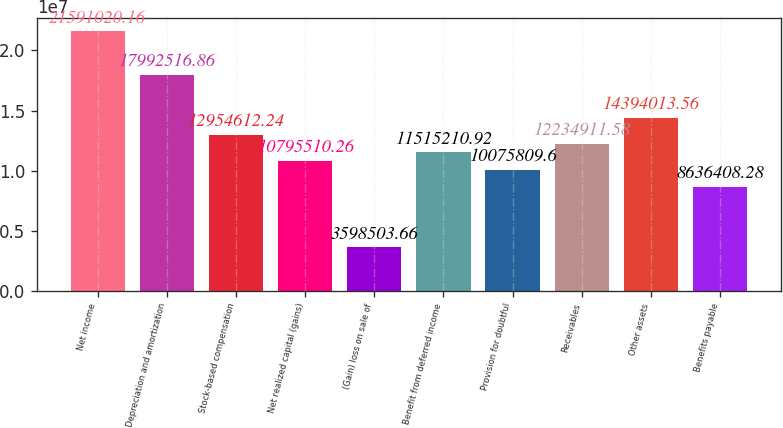Convert chart to OTSL. <chart><loc_0><loc_0><loc_500><loc_500><bar_chart><fcel>Net income<fcel>Depreciation and amortization<fcel>Stock-based compensation<fcel>Net realized capital (gains)<fcel>(Gain) loss on sale of<fcel>Benefit from deferred income<fcel>Provision for doubtful<fcel>Receivables<fcel>Other assets<fcel>Benefits payable<nl><fcel>2.1591e+07<fcel>1.79925e+07<fcel>1.29546e+07<fcel>1.07955e+07<fcel>3.5985e+06<fcel>1.15152e+07<fcel>1.00758e+07<fcel>1.22349e+07<fcel>1.4394e+07<fcel>8.63641e+06<nl></chart> 